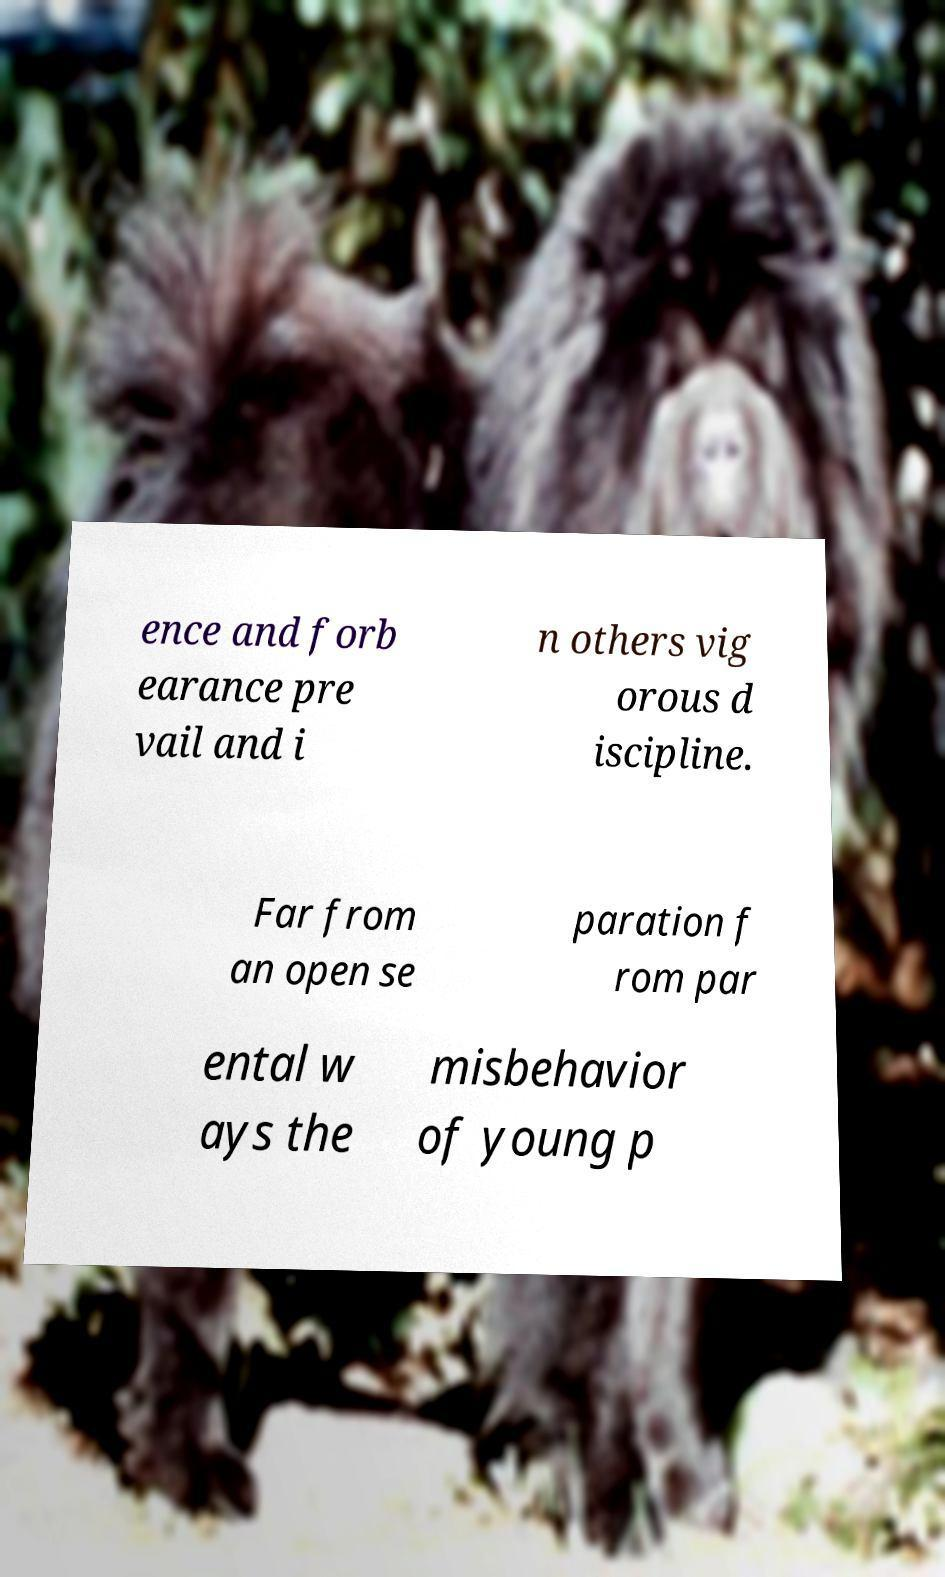Please read and relay the text visible in this image. What does it say? ence and forb earance pre vail and i n others vig orous d iscipline. Far from an open se paration f rom par ental w ays the misbehavior of young p 